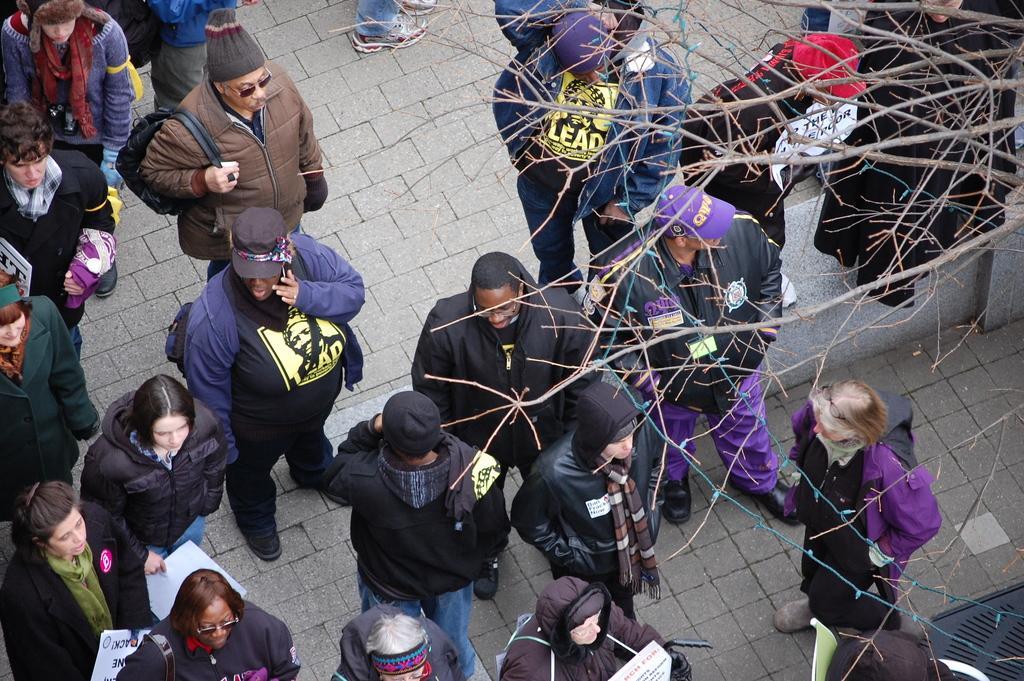In one or two sentences, can you explain what this image depicts? In this image there are group of people standing, and there is a tree. 